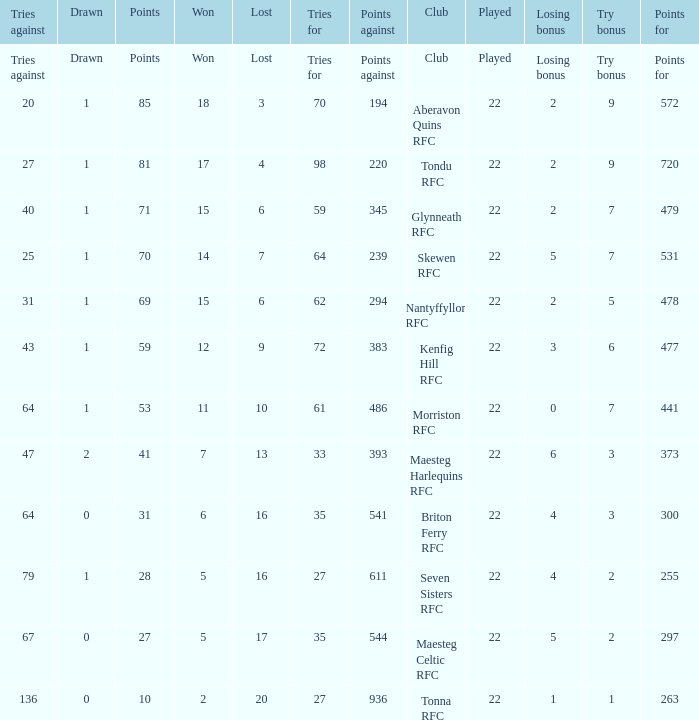How many tries against got the club with 62 tries for? 31.0. 